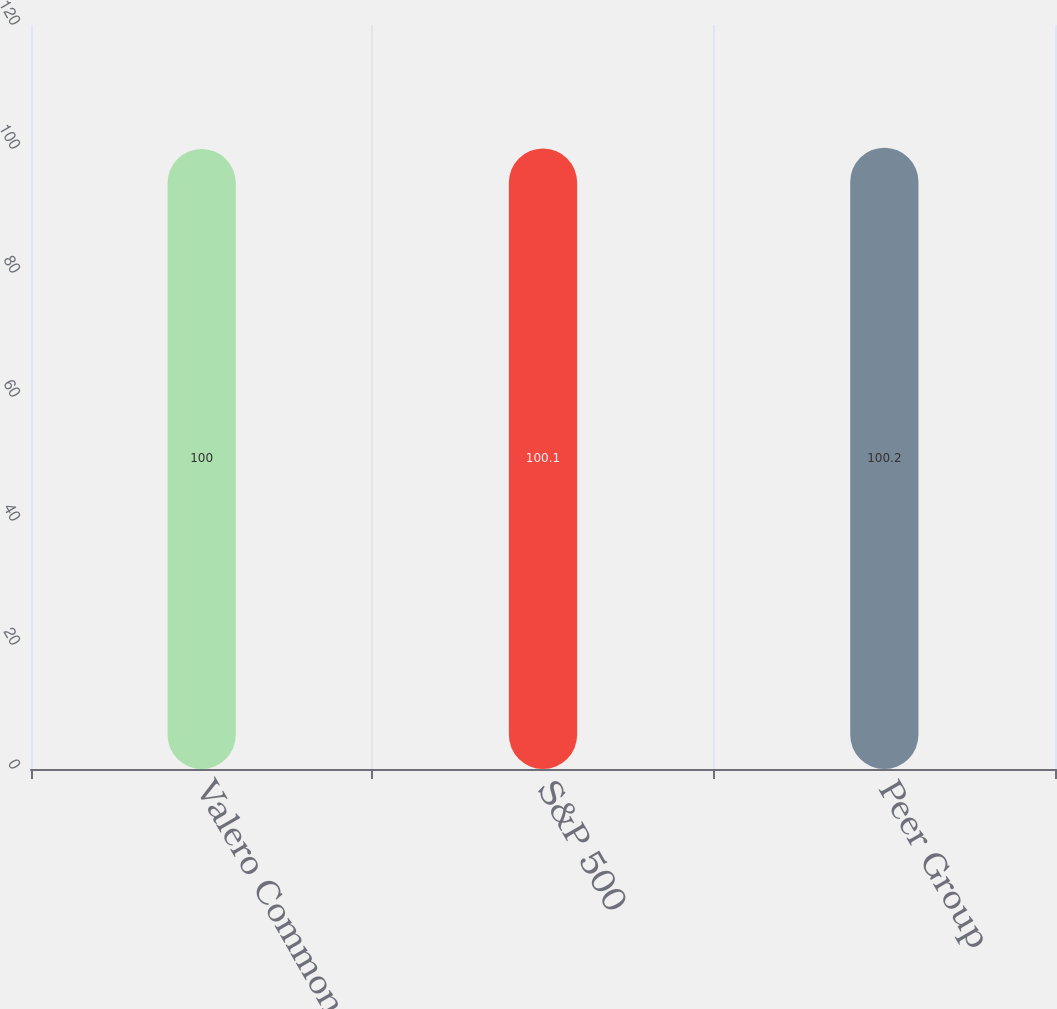Convert chart. <chart><loc_0><loc_0><loc_500><loc_500><bar_chart><fcel>Valero Common Stock<fcel>S&P 500<fcel>Peer Group<nl><fcel>100<fcel>100.1<fcel>100.2<nl></chart> 